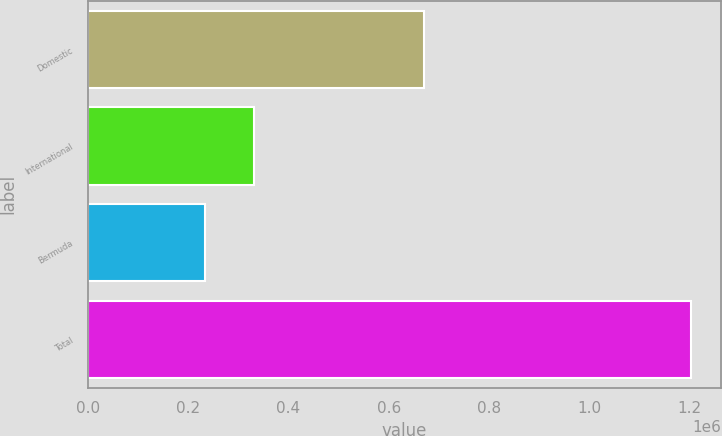Convert chart. <chart><loc_0><loc_0><loc_500><loc_500><bar_chart><fcel>Domestic<fcel>International<fcel>Bermuda<fcel>Total<nl><fcel>669474<fcel>331147<fcel>234382<fcel>1.20204e+06<nl></chart> 